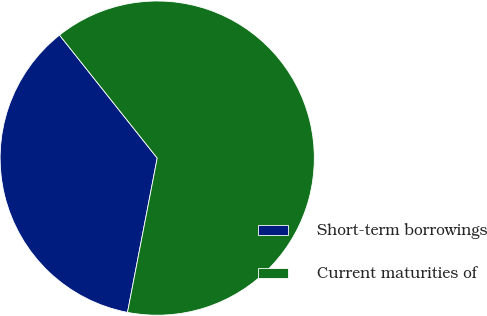<chart> <loc_0><loc_0><loc_500><loc_500><pie_chart><fcel>Short-term borrowings<fcel>Current maturities of<nl><fcel>36.29%<fcel>63.71%<nl></chart> 